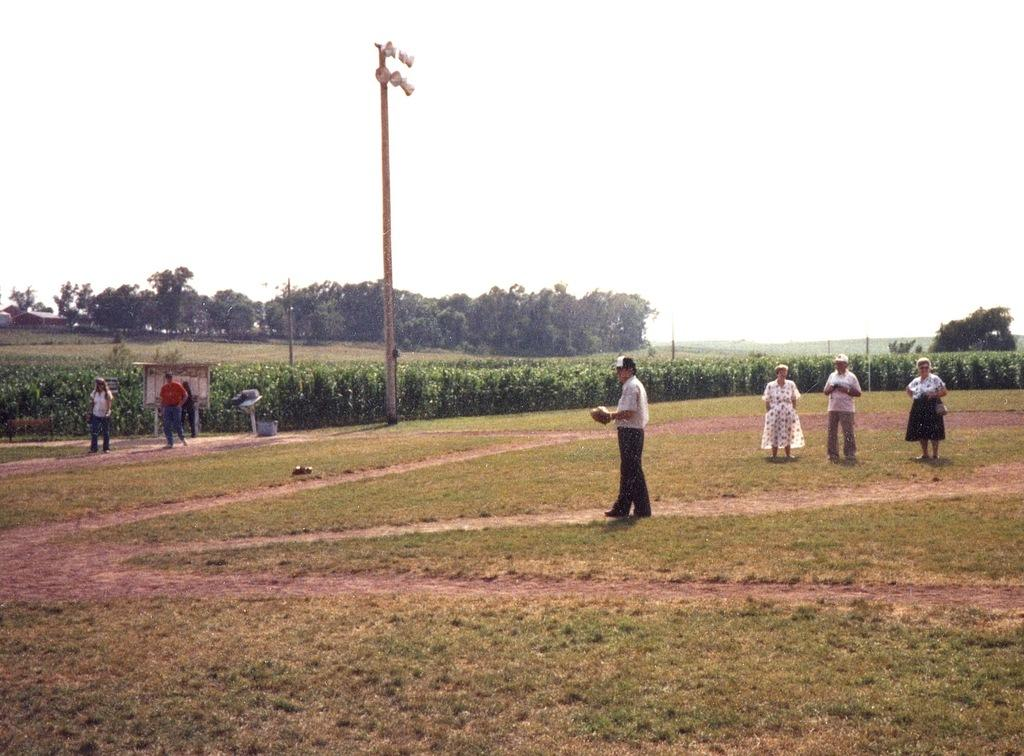How many people are in the group visible in the image? There is a group of people standing in the image, but the exact number cannot be determined from the provided facts. What can be seen in the image besides the group of people? There are poles, plants, and trees visible in the image. What is visible in the background of the image? The sky is visible in the background of the image. What type of silk fabric is draped over the trees in the image? There is no silk fabric present in the image; it features a group of people, poles, plants, trees, and the sky. 